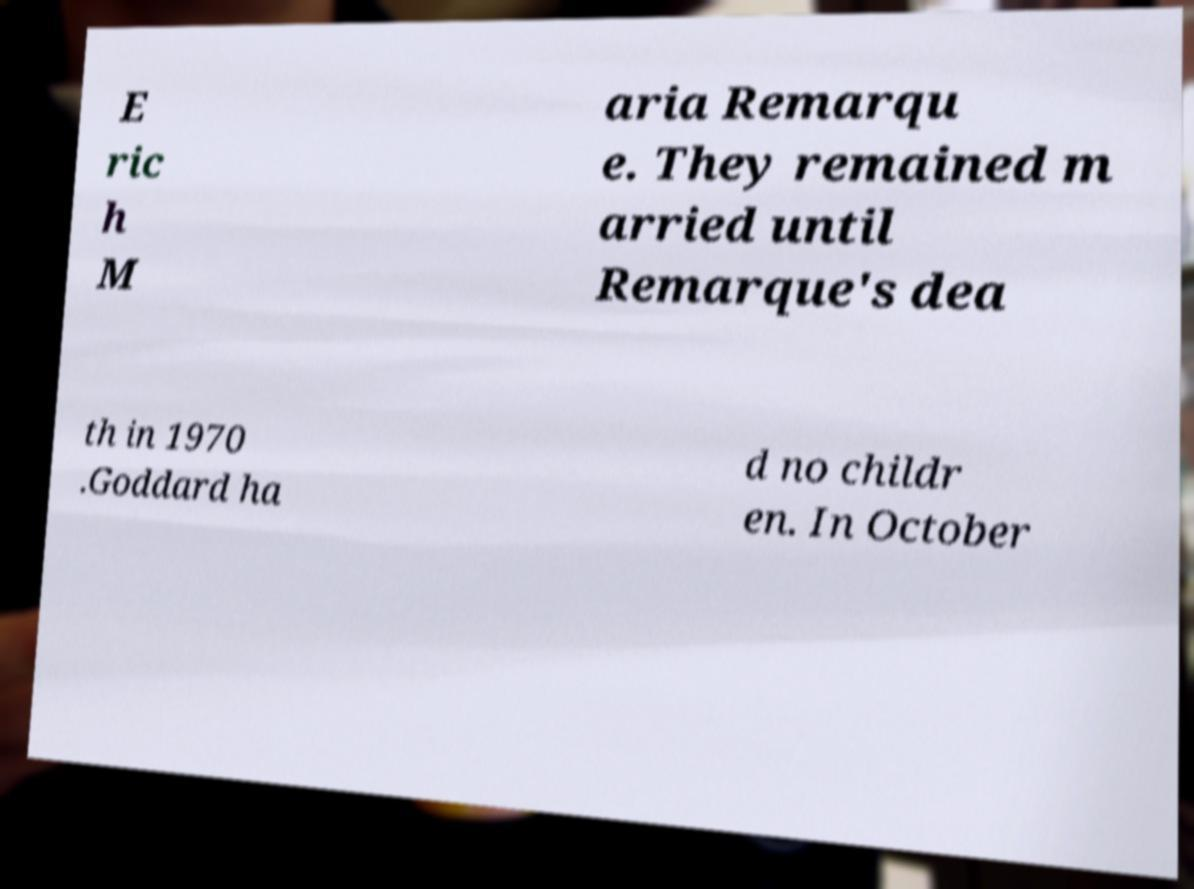For documentation purposes, I need the text within this image transcribed. Could you provide that? E ric h M aria Remarqu e. They remained m arried until Remarque's dea th in 1970 .Goddard ha d no childr en. In October 